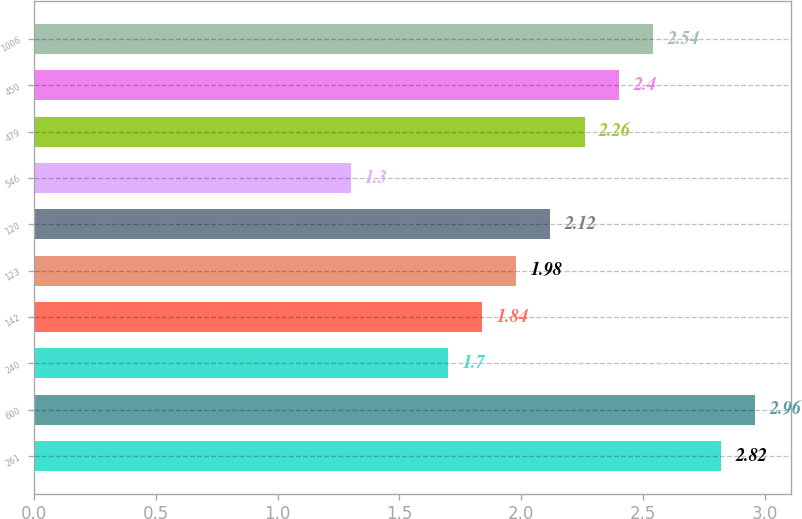Convert chart. <chart><loc_0><loc_0><loc_500><loc_500><bar_chart><fcel>261<fcel>600<fcel>240<fcel>142<fcel>123<fcel>120<fcel>546<fcel>479<fcel>450<fcel>1006<nl><fcel>2.82<fcel>2.96<fcel>1.7<fcel>1.84<fcel>1.98<fcel>2.12<fcel>1.3<fcel>2.26<fcel>2.4<fcel>2.54<nl></chart> 